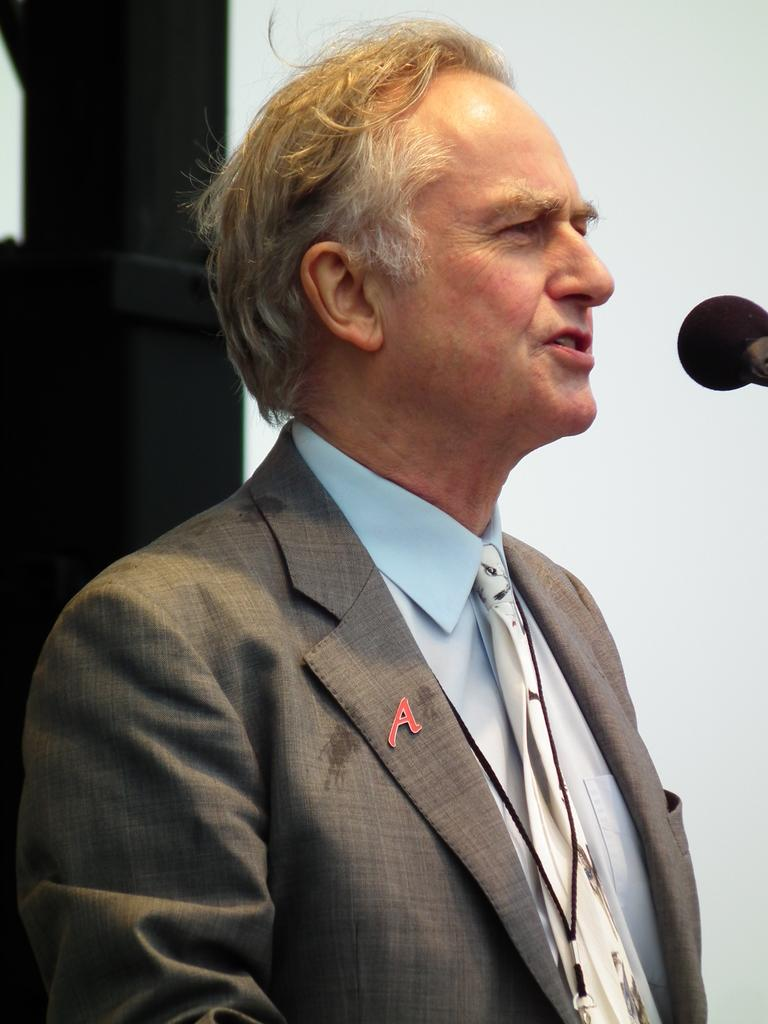What is the main subject in the foreground of the image? There is a person in the foreground of the image. What is the person doing in the image? The person is talking. What is the person using to amplify their voice? There is a microphone in front of the person. Can you describe the background of the image? The background of the image is white. How many eggs are visible on the wall in the image? There are no eggs or walls present in the image. 